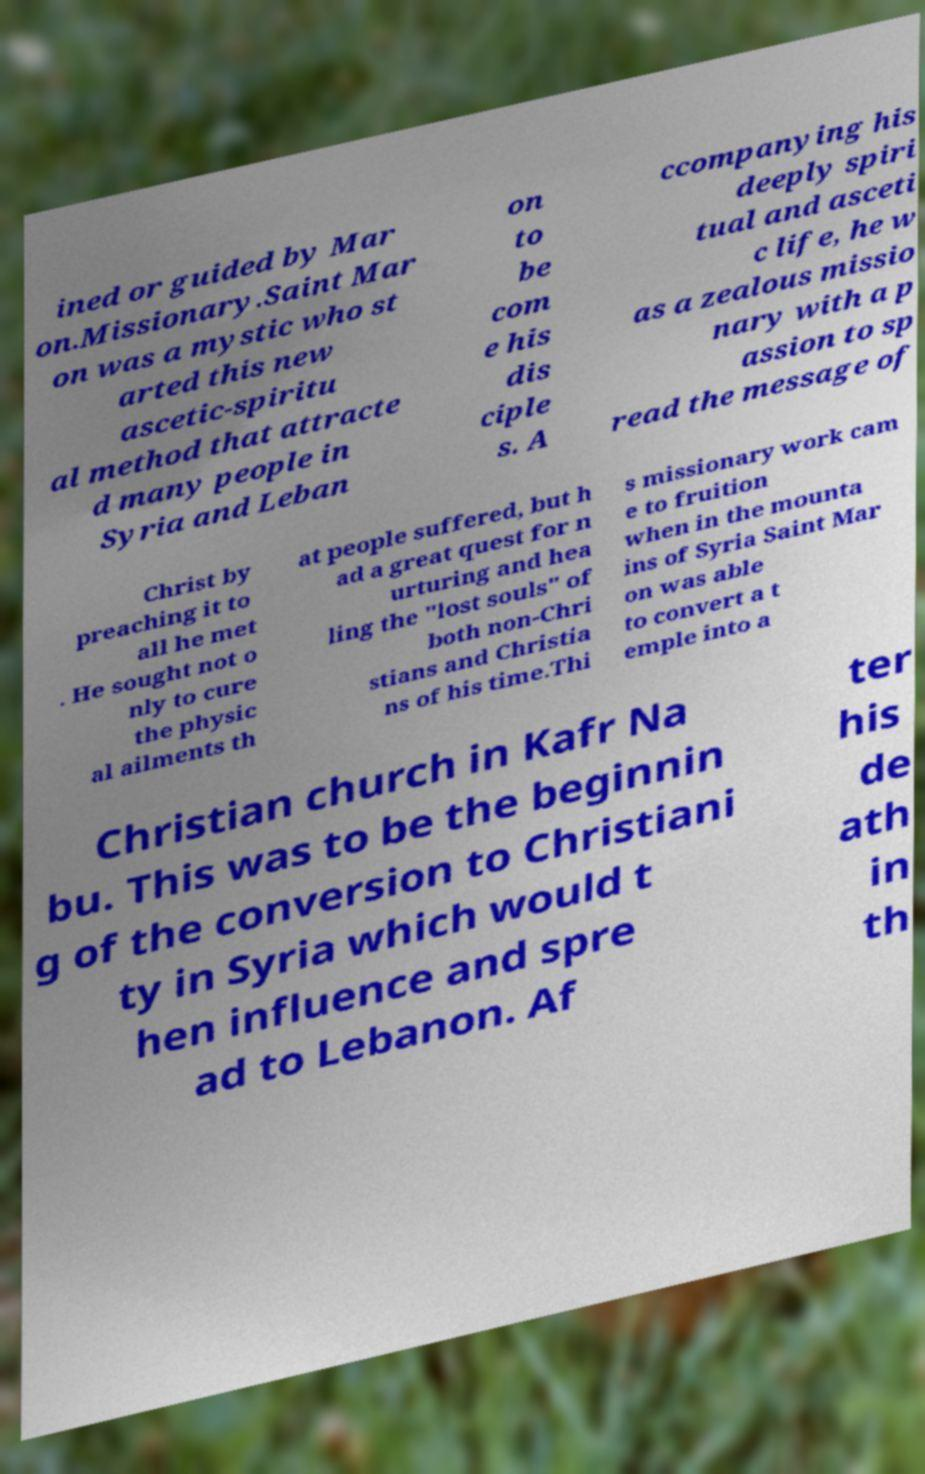For documentation purposes, I need the text within this image transcribed. Could you provide that? ined or guided by Mar on.Missionary.Saint Mar on was a mystic who st arted this new ascetic-spiritu al method that attracte d many people in Syria and Leban on to be com e his dis ciple s. A ccompanying his deeply spiri tual and asceti c life, he w as a zealous missio nary with a p assion to sp read the message of Christ by preaching it to all he met . He sought not o nly to cure the physic al ailments th at people suffered, but h ad a great quest for n urturing and hea ling the "lost souls" of both non-Chri stians and Christia ns of his time.Thi s missionary work cam e to fruition when in the mounta ins of Syria Saint Mar on was able to convert a t emple into a Christian church in Kafr Na bu. This was to be the beginnin g of the conversion to Christiani ty in Syria which would t hen influence and spre ad to Lebanon. Af ter his de ath in th 